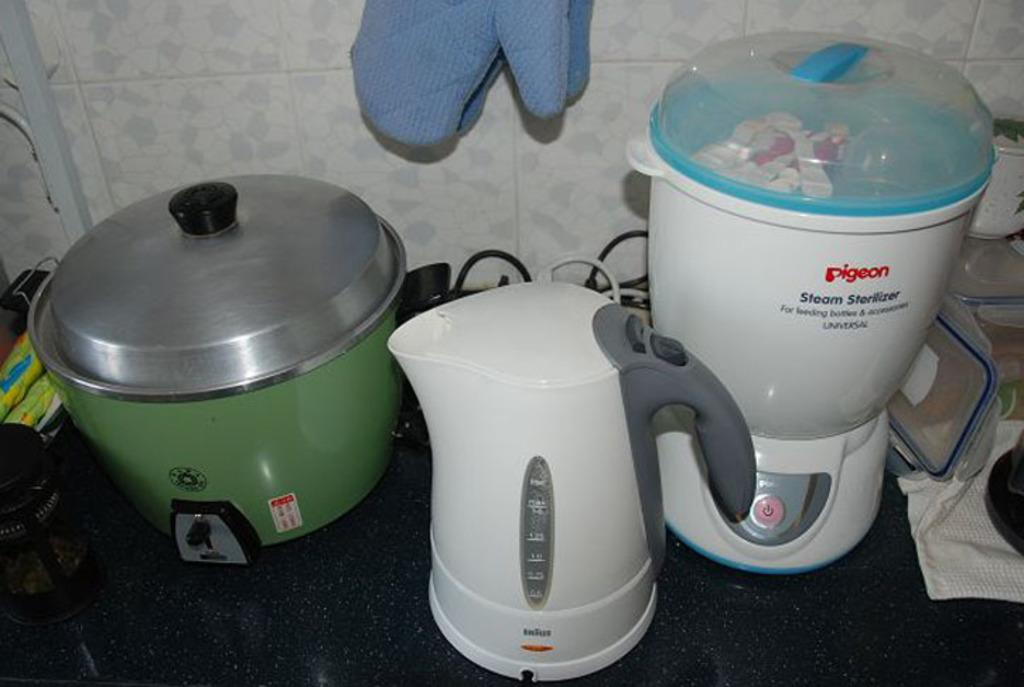<image>
Share a concise interpretation of the image provided. A Pigeon brand steam sterilizer on a kitchen counter. 